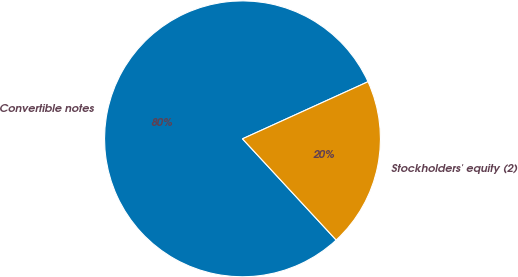Convert chart to OTSL. <chart><loc_0><loc_0><loc_500><loc_500><pie_chart><fcel>Convertible notes<fcel>Stockholders' equity (2)<nl><fcel>80.09%<fcel>19.91%<nl></chart> 